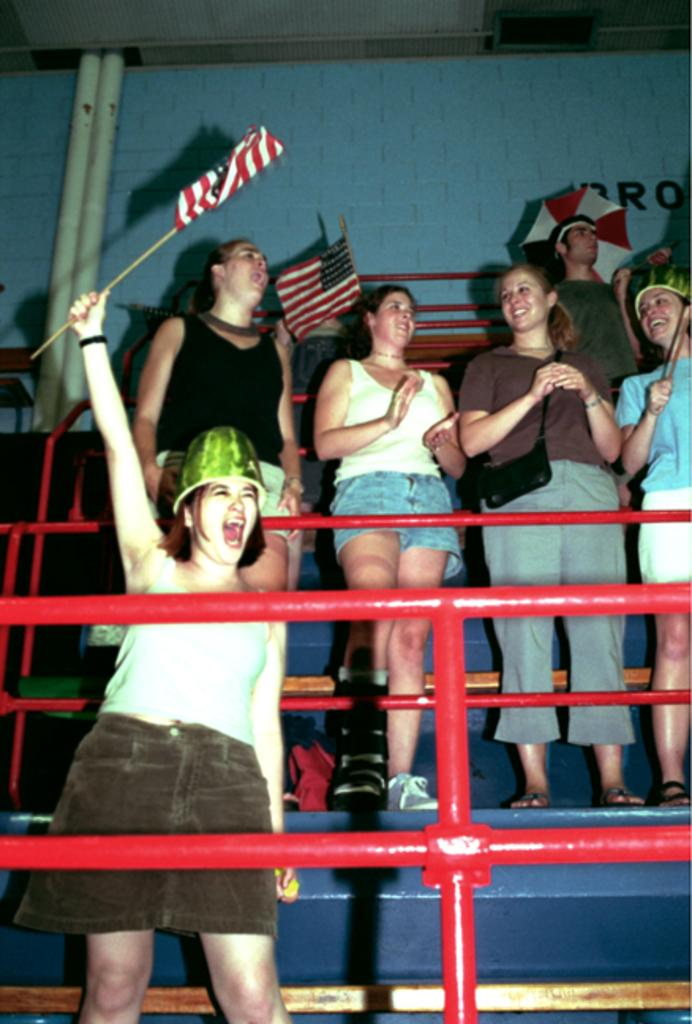What are the people in the image doing? The persons are standing in front of the pipeline. What can be seen in the background of the image? There is a wall in the image. Are there any other elements visible in the image besides the people and the wall? Yes, there are flags visible in the image. How many beds can be seen in the image? There are no beds present in the image. What type of art is displayed on the wall in the image? There is no art displayed on the wall in the image; it is a plain wall. 